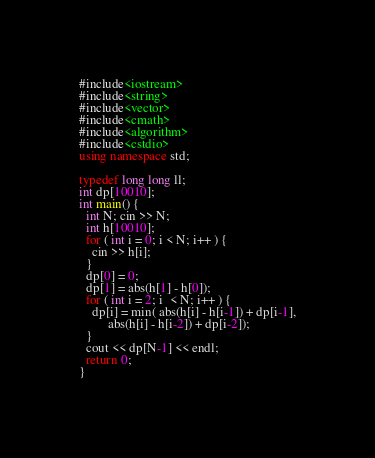<code> <loc_0><loc_0><loc_500><loc_500><_C++_>#include<iostream>
#include<string>
#include<vector>
#include<cmath>
#include<algorithm>
#include<cstdio>
using namespace std;

typedef long long ll;
int dp[10010];
int main() {
  int N; cin >> N;
  int h[10010];
  for ( int i = 0; i < N; i++ ) {
    cin >> h[i];
  }
  dp[0] = 0;
  dp[1] = abs(h[1] - h[0]);
  for ( int i = 2; i  < N; i++ ) {
    dp[i] = min( abs(h[i] - h[i-1]) + dp[i-1],
		 abs(h[i] - h[i-2]) + dp[i-2]);
  }
  cout << dp[N-1] << endl;
  return 0;
}
</code> 